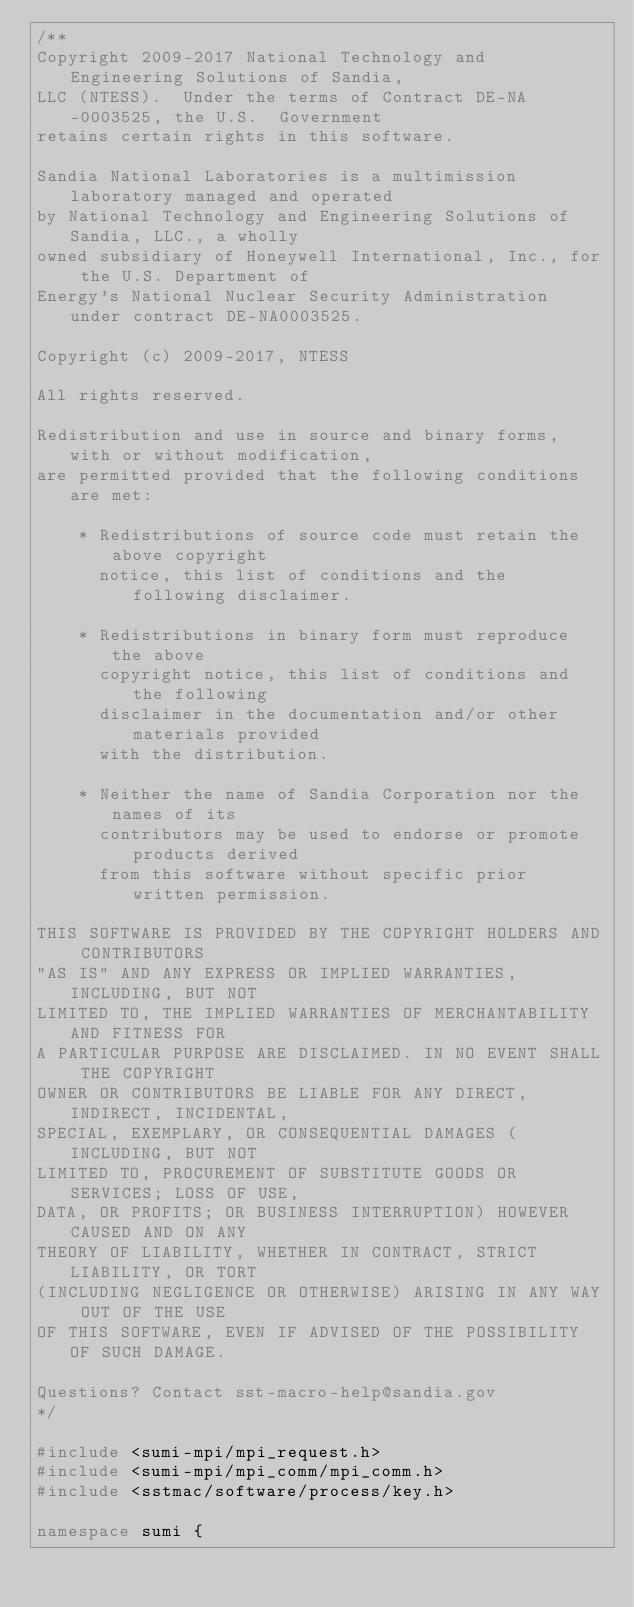<code> <loc_0><loc_0><loc_500><loc_500><_C++_>/**
Copyright 2009-2017 National Technology and Engineering Solutions of Sandia, 
LLC (NTESS).  Under the terms of Contract DE-NA-0003525, the U.S.  Government 
retains certain rights in this software.

Sandia National Laboratories is a multimission laboratory managed and operated
by National Technology and Engineering Solutions of Sandia, LLC., a wholly 
owned subsidiary of Honeywell International, Inc., for the U.S. Department of 
Energy's National Nuclear Security Administration under contract DE-NA0003525.

Copyright (c) 2009-2017, NTESS

All rights reserved.

Redistribution and use in source and binary forms, with or without modification, 
are permitted provided that the following conditions are met:

    * Redistributions of source code must retain the above copyright
      notice, this list of conditions and the following disclaimer.

    * Redistributions in binary form must reproduce the above
      copyright notice, this list of conditions and the following
      disclaimer in the documentation and/or other materials provided
      with the distribution.

    * Neither the name of Sandia Corporation nor the names of its
      contributors may be used to endorse or promote products derived
      from this software without specific prior written permission.

THIS SOFTWARE IS PROVIDED BY THE COPYRIGHT HOLDERS AND CONTRIBUTORS
"AS IS" AND ANY EXPRESS OR IMPLIED WARRANTIES, INCLUDING, BUT NOT
LIMITED TO, THE IMPLIED WARRANTIES OF MERCHANTABILITY AND FITNESS FOR
A PARTICULAR PURPOSE ARE DISCLAIMED. IN NO EVENT SHALL THE COPYRIGHT
OWNER OR CONTRIBUTORS BE LIABLE FOR ANY DIRECT, INDIRECT, INCIDENTAL,
SPECIAL, EXEMPLARY, OR CONSEQUENTIAL DAMAGES (INCLUDING, BUT NOT
LIMITED TO, PROCUREMENT OF SUBSTITUTE GOODS OR SERVICES; LOSS OF USE,
DATA, OR PROFITS; OR BUSINESS INTERRUPTION) HOWEVER CAUSED AND ON ANY
THEORY OF LIABILITY, WHETHER IN CONTRACT, STRICT LIABILITY, OR TORT
(INCLUDING NEGLIGENCE OR OTHERWISE) ARISING IN ANY WAY OUT OF THE USE
OF THIS SOFTWARE, EVEN IF ADVISED OF THE POSSIBILITY OF SUCH DAMAGE.

Questions? Contact sst-macro-help@sandia.gov
*/

#include <sumi-mpi/mpi_request.h>
#include <sumi-mpi/mpi_comm/mpi_comm.h>
#include <sstmac/software/process/key.h>

namespace sumi {
</code> 